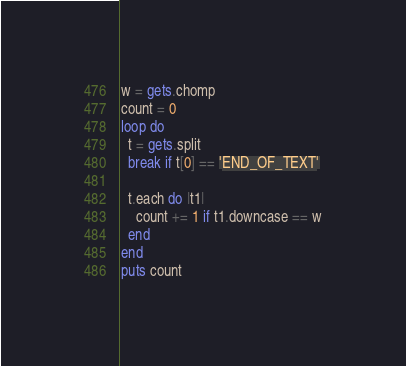<code> <loc_0><loc_0><loc_500><loc_500><_Ruby_>w = gets.chomp
count = 0
loop do
  t = gets.split
  break if t[0] == 'END_OF_TEXT'

  t.each do |t1|
    count += 1 if t1.downcase == w
  end
end
puts count

</code> 